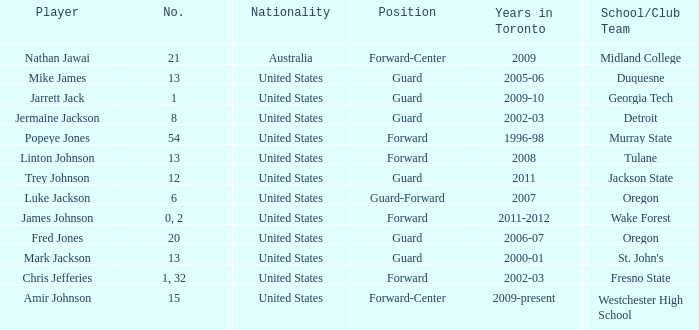Who are all of the players on the Westchester High School club team? Amir Johnson. 